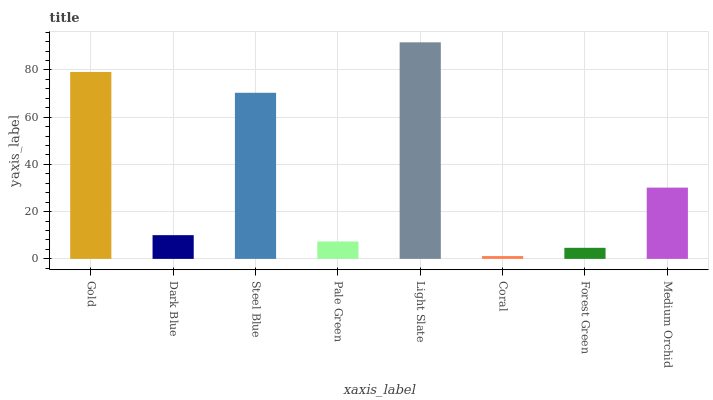Is Dark Blue the minimum?
Answer yes or no. No. Is Dark Blue the maximum?
Answer yes or no. No. Is Gold greater than Dark Blue?
Answer yes or no. Yes. Is Dark Blue less than Gold?
Answer yes or no. Yes. Is Dark Blue greater than Gold?
Answer yes or no. No. Is Gold less than Dark Blue?
Answer yes or no. No. Is Medium Orchid the high median?
Answer yes or no. Yes. Is Dark Blue the low median?
Answer yes or no. Yes. Is Coral the high median?
Answer yes or no. No. Is Steel Blue the low median?
Answer yes or no. No. 